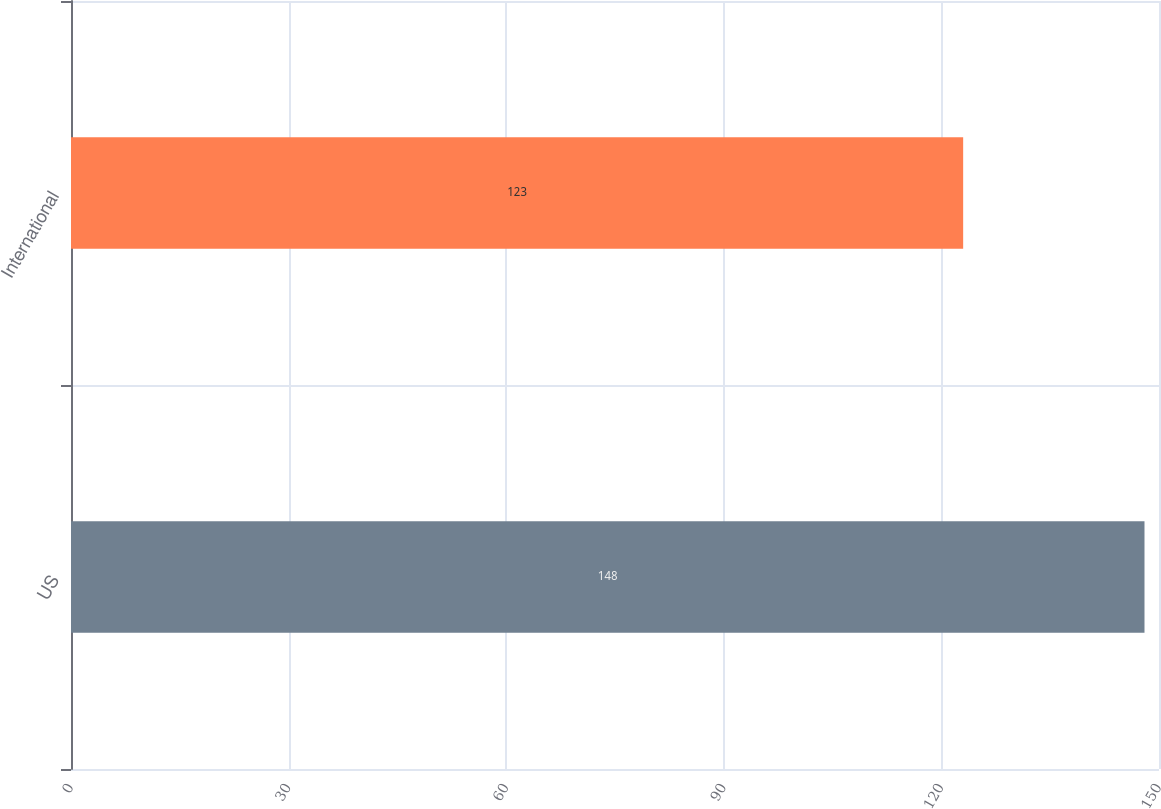<chart> <loc_0><loc_0><loc_500><loc_500><bar_chart><fcel>US<fcel>International<nl><fcel>148<fcel>123<nl></chart> 